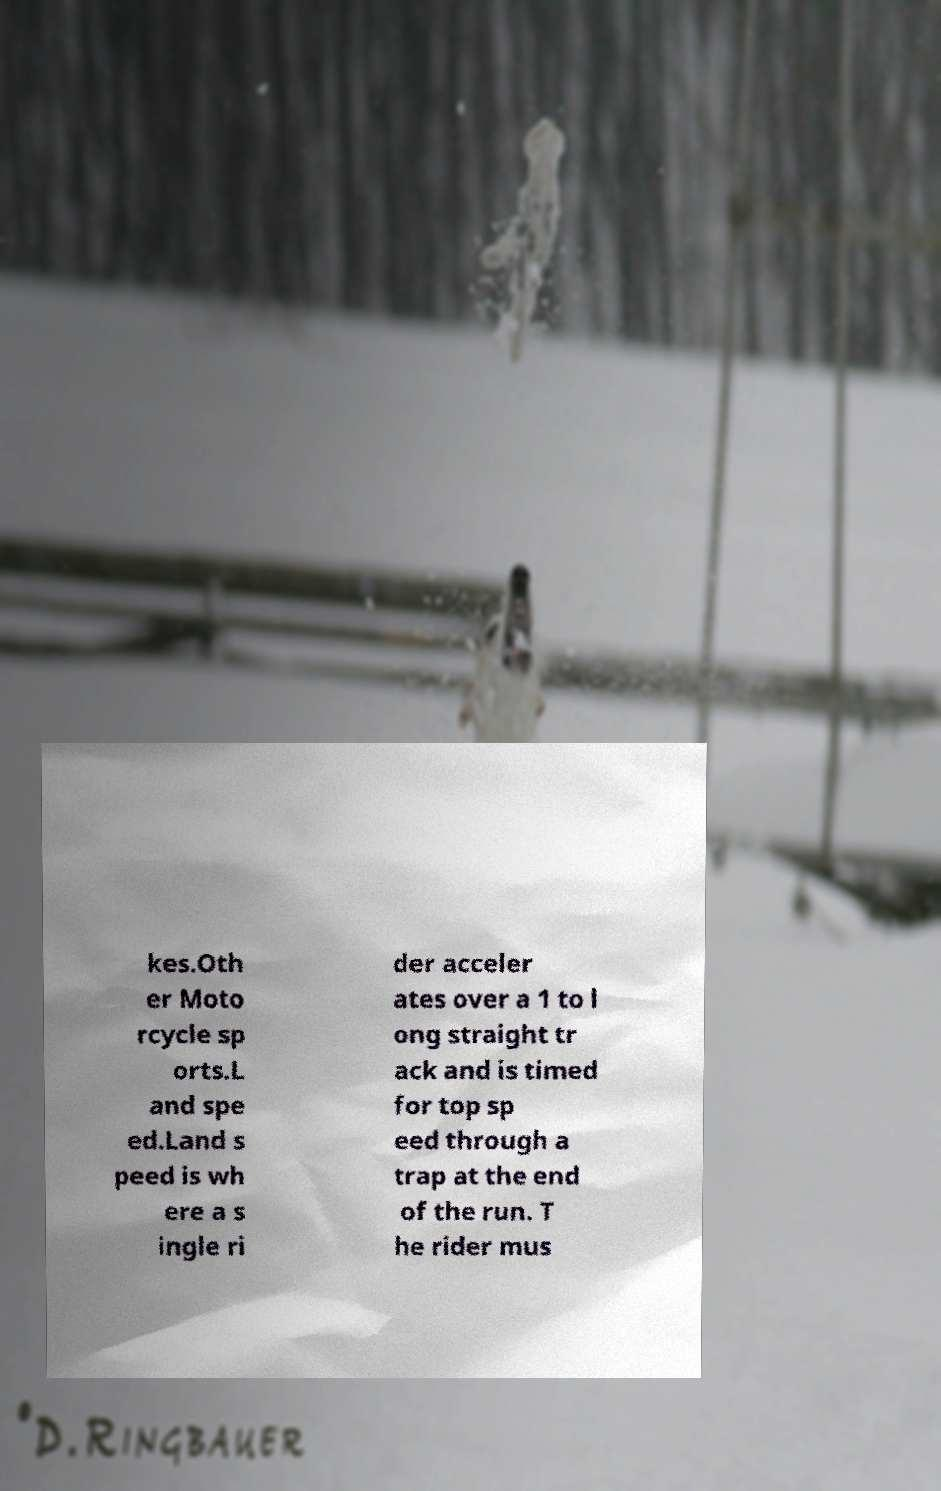Can you accurately transcribe the text from the provided image for me? kes.Oth er Moto rcycle sp orts.L and spe ed.Land s peed is wh ere a s ingle ri der acceler ates over a 1 to l ong straight tr ack and is timed for top sp eed through a trap at the end of the run. T he rider mus 